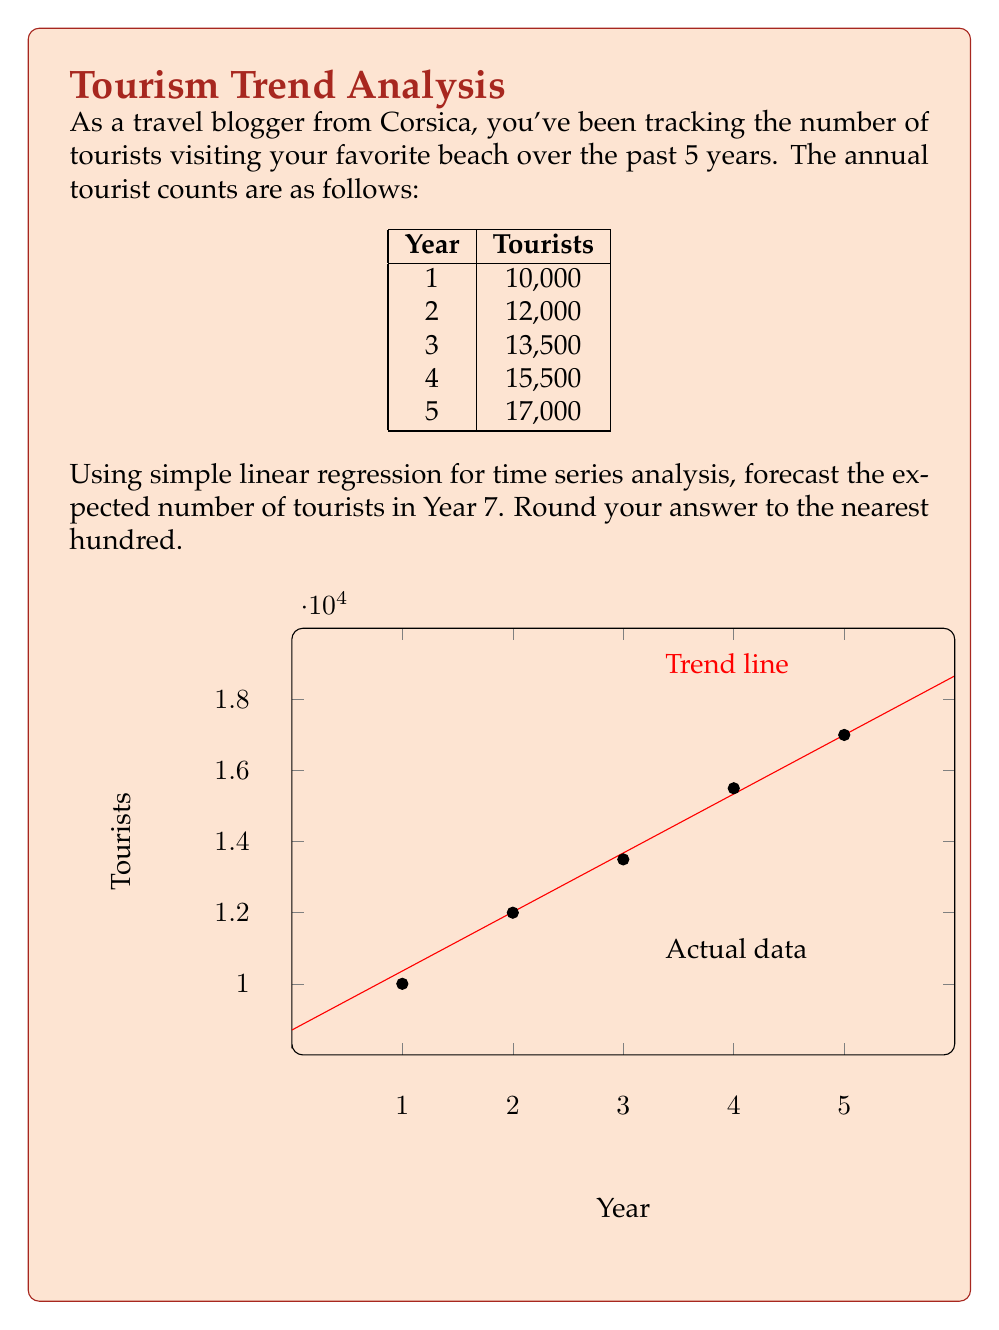What is the answer to this math problem? To forecast future tourism growth using simple linear regression, we'll follow these steps:

1) First, let's calculate the means of x (years) and y (tourists):
   $\bar{x} = \frac{1+2+3+4+5}{5} = 3$
   $\bar{y} = \frac{10000+12000+13500+15500+17000}{5} = 13600$

2) Now, we'll calculate the slope (b) of the regression line:
   $b = \frac{\sum(x_i - \bar{x})(y_i - \bar{y})}{\sum(x_i - \bar{x})^2}$

   $\sum(x_i - \bar{x})^2 = (-2)^2 + (-1)^2 + 0^2 + 1^2 + 2^2 = 10$

   $\sum(x_i - \bar{x})(y_i - \bar{y}) = (-2)(-3600) + (-1)(-1600) + 0(-100) + 1(1900) + 2(3400) = 16600$

   $b = \frac{16600}{10} = 1660$

3) We can now find the y-intercept (a):
   $a = \bar{y} - b\bar{x} = 13600 - 1660(3) = 8700$

4) Our regression line equation is:
   $y = 8700 + 1660x$

5) To forecast Year 7, we substitute x = 7:
   $y = 8700 + 1660(7) = 20320$

6) Rounding to the nearest hundred:
   20,300
Answer: 20,300 tourists 